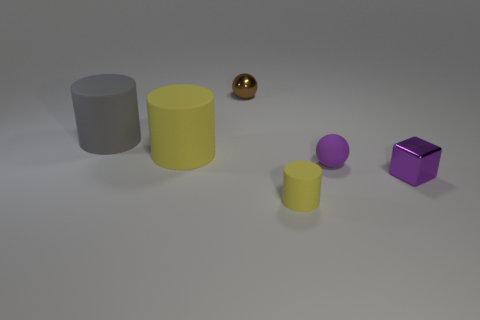Subtract all yellow cylinders. How many cylinders are left? 1 Subtract all yellow spheres. How many yellow cylinders are left? 2 Add 4 small brown spheres. How many objects exist? 10 Subtract all blocks. How many objects are left? 5 Subtract 1 purple spheres. How many objects are left? 5 Subtract all purple balls. Subtract all purple cylinders. How many balls are left? 1 Subtract all yellow rubber cylinders. Subtract all tiny purple matte things. How many objects are left? 3 Add 2 big gray cylinders. How many big gray cylinders are left? 3 Add 4 tiny purple rubber things. How many tiny purple rubber things exist? 5 